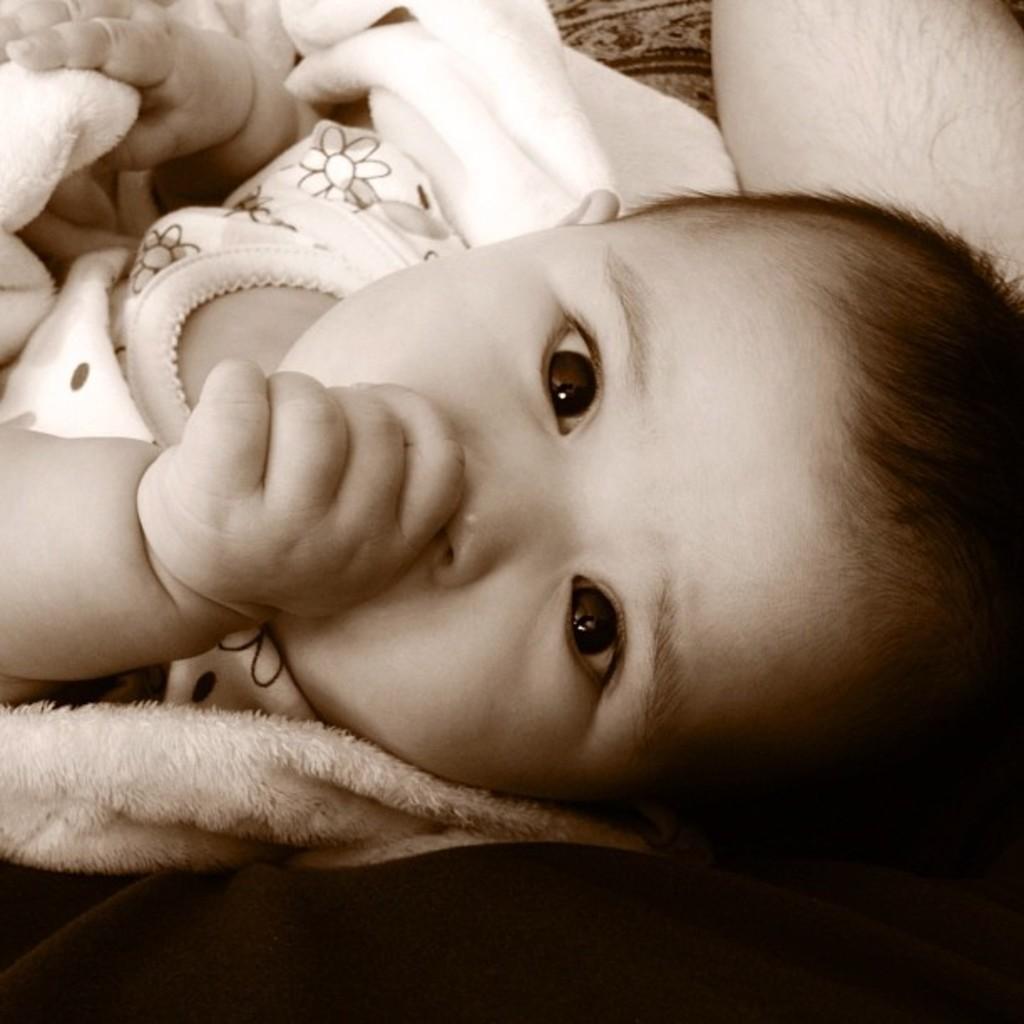In one or two sentences, can you explain what this image depicts? At the bottom of the image a person is sitting and holding a baby. 